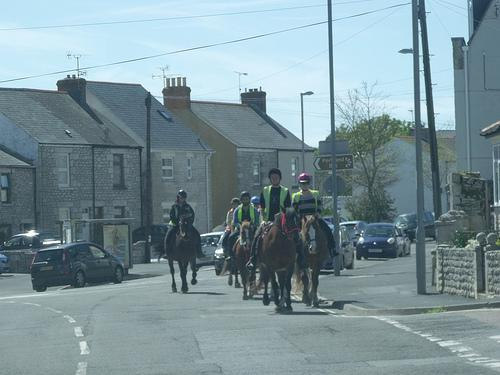Question: what are the people riding?
Choices:
A. Donkey.
B. Horses.
C. Camel.
D. Car.
Answer with the letter. Answer: B Question: what is on top of the buildings?
Choices:
A. Sniper.
B. Roof.
C. Chimneys.
D. Flowers.
Answer with the letter. Answer: C Question: how many chimneys are there?
Choices:
A. 1.
B. 2.
C. 4.
D. 3.
Answer with the letter. Answer: D Question: what is parked on the side of the road?
Choices:
A. Truck.
B. Trailer.
C. Van.
D. Cars.
Answer with the letter. Answer: D Question: why are the people riding?
Choices:
A. For learning.
B. Recreation.
C. To gather other animals.
D. To get somewhere.
Answer with the letter. Answer: B Question: who is wearing helmets?
Choices:
A. The kids.
B. The women.
C. The men.
D. The riders.
Answer with the letter. Answer: D 